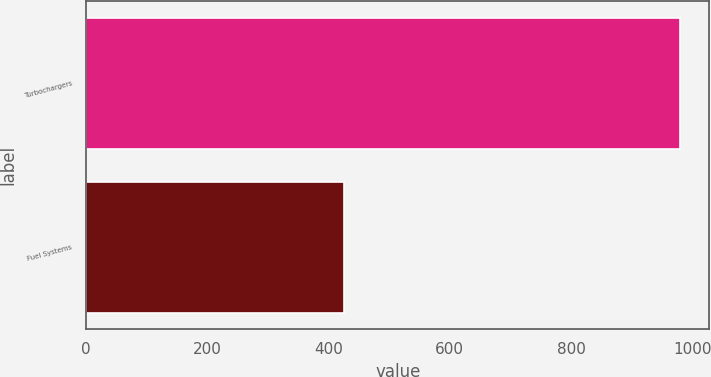<chart> <loc_0><loc_0><loc_500><loc_500><bar_chart><fcel>Turbochargers<fcel>Fuel Systems<nl><fcel>979<fcel>426<nl></chart> 